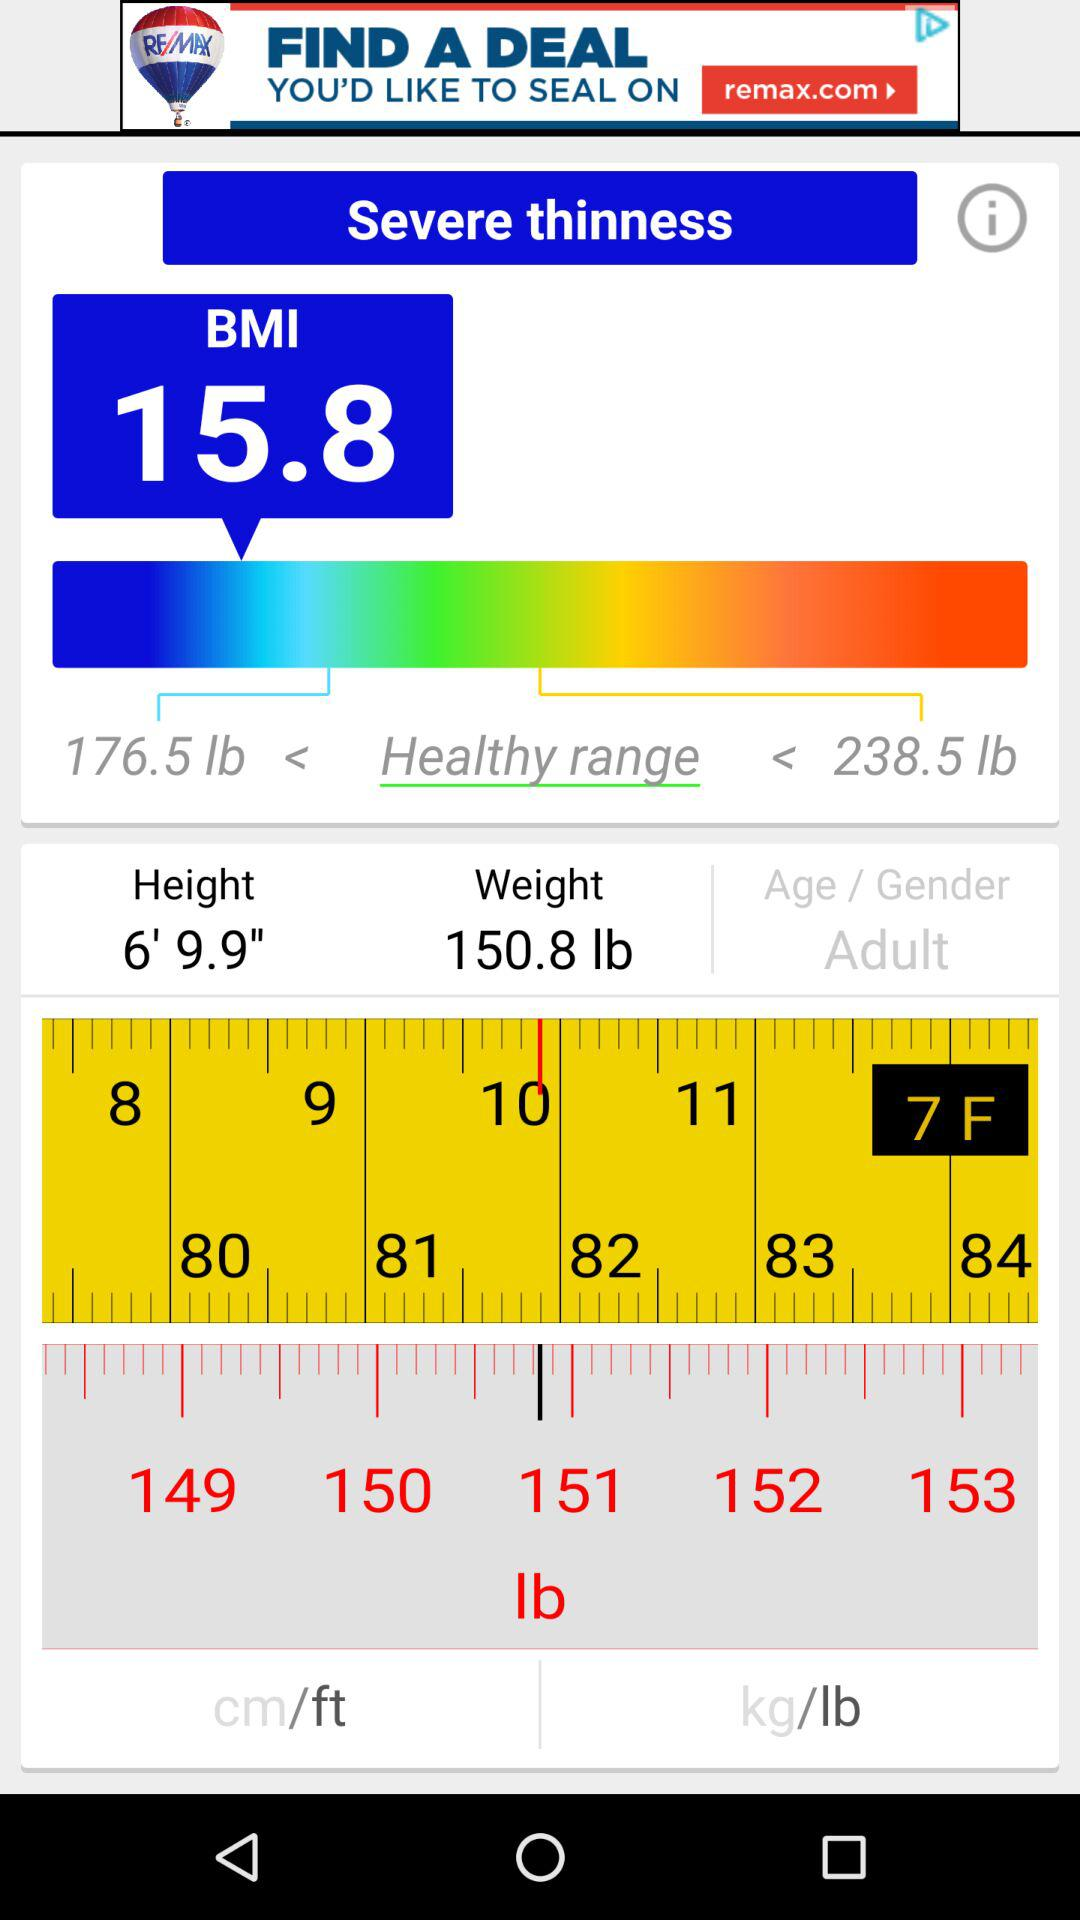What is the weight? The weight is 150.8 lbs. 